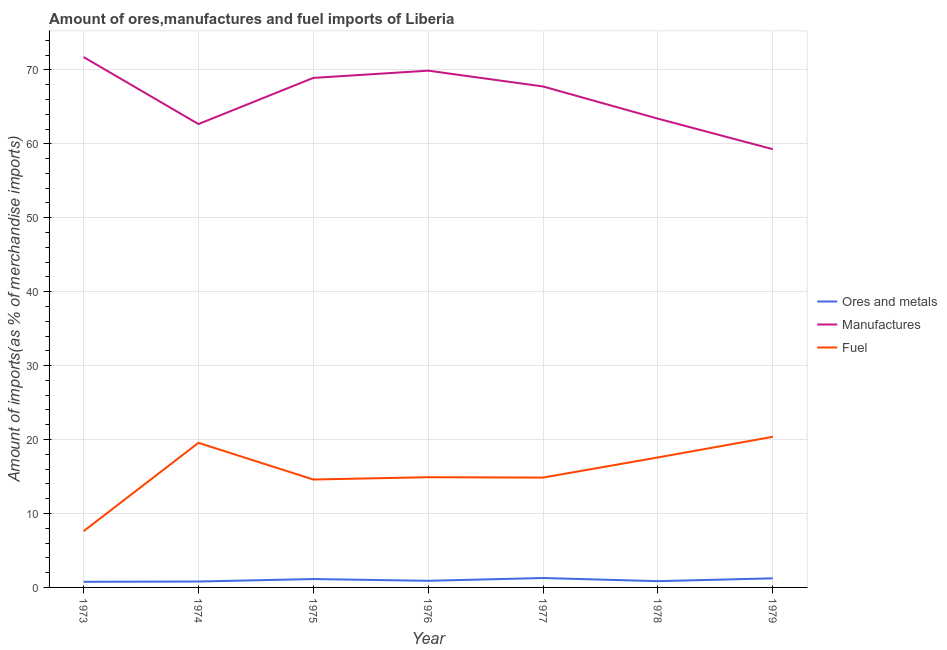How many different coloured lines are there?
Offer a terse response. 3. Does the line corresponding to percentage of fuel imports intersect with the line corresponding to percentage of ores and metals imports?
Offer a terse response. No. What is the percentage of manufactures imports in 1977?
Offer a very short reply. 67.76. Across all years, what is the maximum percentage of fuel imports?
Provide a short and direct response. 20.37. Across all years, what is the minimum percentage of manufactures imports?
Ensure brevity in your answer.  59.27. In which year was the percentage of fuel imports minimum?
Your answer should be very brief. 1973. What is the total percentage of manufactures imports in the graph?
Make the answer very short. 463.64. What is the difference between the percentage of fuel imports in 1975 and that in 1977?
Your answer should be compact. -0.26. What is the difference between the percentage of ores and metals imports in 1974 and the percentage of fuel imports in 1973?
Keep it short and to the point. -6.81. What is the average percentage of ores and metals imports per year?
Offer a terse response. 0.99. In the year 1975, what is the difference between the percentage of manufactures imports and percentage of ores and metals imports?
Your response must be concise. 67.78. In how many years, is the percentage of manufactures imports greater than 46 %?
Ensure brevity in your answer.  7. What is the ratio of the percentage of fuel imports in 1974 to that in 1977?
Keep it short and to the point. 1.32. Is the percentage of ores and metals imports in 1974 less than that in 1979?
Your answer should be very brief. Yes. Is the difference between the percentage of ores and metals imports in 1975 and 1976 greater than the difference between the percentage of fuel imports in 1975 and 1976?
Give a very brief answer. Yes. What is the difference between the highest and the second highest percentage of fuel imports?
Make the answer very short. 0.81. What is the difference between the highest and the lowest percentage of manufactures imports?
Offer a very short reply. 12.46. Is the sum of the percentage of manufactures imports in 1975 and 1977 greater than the maximum percentage of ores and metals imports across all years?
Ensure brevity in your answer.  Yes. Does the percentage of ores and metals imports monotonically increase over the years?
Your response must be concise. No. Is the percentage of ores and metals imports strictly greater than the percentage of fuel imports over the years?
Keep it short and to the point. No. Is the percentage of ores and metals imports strictly less than the percentage of manufactures imports over the years?
Offer a very short reply. Yes. How many lines are there?
Your response must be concise. 3. What is the difference between two consecutive major ticks on the Y-axis?
Keep it short and to the point. 10. Where does the legend appear in the graph?
Give a very brief answer. Center right. How many legend labels are there?
Make the answer very short. 3. What is the title of the graph?
Provide a succinct answer. Amount of ores,manufactures and fuel imports of Liberia. Does "Czech Republic" appear as one of the legend labels in the graph?
Your answer should be compact. No. What is the label or title of the Y-axis?
Your answer should be very brief. Amount of imports(as % of merchandise imports). What is the Amount of imports(as % of merchandise imports) of Ores and metals in 1973?
Keep it short and to the point. 0.76. What is the Amount of imports(as % of merchandise imports) of Manufactures in 1973?
Provide a short and direct response. 71.73. What is the Amount of imports(as % of merchandise imports) in Fuel in 1973?
Offer a terse response. 7.61. What is the Amount of imports(as % of merchandise imports) in Ores and metals in 1974?
Your answer should be very brief. 0.8. What is the Amount of imports(as % of merchandise imports) of Manufactures in 1974?
Offer a terse response. 62.67. What is the Amount of imports(as % of merchandise imports) of Fuel in 1974?
Your answer should be compact. 19.56. What is the Amount of imports(as % of merchandise imports) in Ores and metals in 1975?
Keep it short and to the point. 1.13. What is the Amount of imports(as % of merchandise imports) in Manufactures in 1975?
Offer a terse response. 68.91. What is the Amount of imports(as % of merchandise imports) of Fuel in 1975?
Make the answer very short. 14.6. What is the Amount of imports(as % of merchandise imports) of Ores and metals in 1976?
Offer a terse response. 0.9. What is the Amount of imports(as % of merchandise imports) in Manufactures in 1976?
Give a very brief answer. 69.89. What is the Amount of imports(as % of merchandise imports) of Fuel in 1976?
Provide a short and direct response. 14.91. What is the Amount of imports(as % of merchandise imports) in Ores and metals in 1977?
Provide a succinct answer. 1.27. What is the Amount of imports(as % of merchandise imports) in Manufactures in 1977?
Ensure brevity in your answer.  67.76. What is the Amount of imports(as % of merchandise imports) in Fuel in 1977?
Your answer should be very brief. 14.86. What is the Amount of imports(as % of merchandise imports) in Ores and metals in 1978?
Make the answer very short. 0.85. What is the Amount of imports(as % of merchandise imports) of Manufactures in 1978?
Offer a very short reply. 63.4. What is the Amount of imports(as % of merchandise imports) in Fuel in 1978?
Your answer should be compact. 17.58. What is the Amount of imports(as % of merchandise imports) in Ores and metals in 1979?
Give a very brief answer. 1.23. What is the Amount of imports(as % of merchandise imports) of Manufactures in 1979?
Offer a terse response. 59.27. What is the Amount of imports(as % of merchandise imports) of Fuel in 1979?
Give a very brief answer. 20.37. Across all years, what is the maximum Amount of imports(as % of merchandise imports) of Ores and metals?
Make the answer very short. 1.27. Across all years, what is the maximum Amount of imports(as % of merchandise imports) in Manufactures?
Provide a succinct answer. 71.73. Across all years, what is the maximum Amount of imports(as % of merchandise imports) in Fuel?
Ensure brevity in your answer.  20.37. Across all years, what is the minimum Amount of imports(as % of merchandise imports) in Ores and metals?
Offer a terse response. 0.76. Across all years, what is the minimum Amount of imports(as % of merchandise imports) in Manufactures?
Offer a very short reply. 59.27. Across all years, what is the minimum Amount of imports(as % of merchandise imports) in Fuel?
Make the answer very short. 7.61. What is the total Amount of imports(as % of merchandise imports) in Ores and metals in the graph?
Offer a terse response. 6.94. What is the total Amount of imports(as % of merchandise imports) in Manufactures in the graph?
Ensure brevity in your answer.  463.64. What is the total Amount of imports(as % of merchandise imports) of Fuel in the graph?
Your response must be concise. 109.47. What is the difference between the Amount of imports(as % of merchandise imports) in Ores and metals in 1973 and that in 1974?
Keep it short and to the point. -0.04. What is the difference between the Amount of imports(as % of merchandise imports) in Manufactures in 1973 and that in 1974?
Your answer should be very brief. 9.06. What is the difference between the Amount of imports(as % of merchandise imports) of Fuel in 1973 and that in 1974?
Ensure brevity in your answer.  -11.95. What is the difference between the Amount of imports(as % of merchandise imports) of Ores and metals in 1973 and that in 1975?
Your answer should be very brief. -0.37. What is the difference between the Amount of imports(as % of merchandise imports) in Manufactures in 1973 and that in 1975?
Make the answer very short. 2.82. What is the difference between the Amount of imports(as % of merchandise imports) of Fuel in 1973 and that in 1975?
Ensure brevity in your answer.  -6.99. What is the difference between the Amount of imports(as % of merchandise imports) in Ores and metals in 1973 and that in 1976?
Offer a very short reply. -0.14. What is the difference between the Amount of imports(as % of merchandise imports) of Manufactures in 1973 and that in 1976?
Give a very brief answer. 1.84. What is the difference between the Amount of imports(as % of merchandise imports) of Fuel in 1973 and that in 1976?
Provide a short and direct response. -7.3. What is the difference between the Amount of imports(as % of merchandise imports) of Ores and metals in 1973 and that in 1977?
Ensure brevity in your answer.  -0.51. What is the difference between the Amount of imports(as % of merchandise imports) of Manufactures in 1973 and that in 1977?
Give a very brief answer. 3.98. What is the difference between the Amount of imports(as % of merchandise imports) in Fuel in 1973 and that in 1977?
Your answer should be very brief. -7.25. What is the difference between the Amount of imports(as % of merchandise imports) in Ores and metals in 1973 and that in 1978?
Offer a very short reply. -0.09. What is the difference between the Amount of imports(as % of merchandise imports) in Manufactures in 1973 and that in 1978?
Ensure brevity in your answer.  8.33. What is the difference between the Amount of imports(as % of merchandise imports) in Fuel in 1973 and that in 1978?
Offer a terse response. -9.97. What is the difference between the Amount of imports(as % of merchandise imports) in Ores and metals in 1973 and that in 1979?
Your answer should be compact. -0.47. What is the difference between the Amount of imports(as % of merchandise imports) of Manufactures in 1973 and that in 1979?
Offer a terse response. 12.46. What is the difference between the Amount of imports(as % of merchandise imports) of Fuel in 1973 and that in 1979?
Your answer should be compact. -12.76. What is the difference between the Amount of imports(as % of merchandise imports) of Ores and metals in 1974 and that in 1975?
Make the answer very short. -0.33. What is the difference between the Amount of imports(as % of merchandise imports) in Manufactures in 1974 and that in 1975?
Give a very brief answer. -6.24. What is the difference between the Amount of imports(as % of merchandise imports) in Fuel in 1974 and that in 1975?
Your response must be concise. 4.96. What is the difference between the Amount of imports(as % of merchandise imports) in Ores and metals in 1974 and that in 1976?
Your answer should be compact. -0.1. What is the difference between the Amount of imports(as % of merchandise imports) in Manufactures in 1974 and that in 1976?
Provide a short and direct response. -7.22. What is the difference between the Amount of imports(as % of merchandise imports) of Fuel in 1974 and that in 1976?
Ensure brevity in your answer.  4.65. What is the difference between the Amount of imports(as % of merchandise imports) of Ores and metals in 1974 and that in 1977?
Keep it short and to the point. -0.48. What is the difference between the Amount of imports(as % of merchandise imports) in Manufactures in 1974 and that in 1977?
Make the answer very short. -5.08. What is the difference between the Amount of imports(as % of merchandise imports) in Fuel in 1974 and that in 1977?
Provide a succinct answer. 4.7. What is the difference between the Amount of imports(as % of merchandise imports) in Ores and metals in 1974 and that in 1978?
Ensure brevity in your answer.  -0.05. What is the difference between the Amount of imports(as % of merchandise imports) of Manufactures in 1974 and that in 1978?
Offer a terse response. -0.73. What is the difference between the Amount of imports(as % of merchandise imports) of Fuel in 1974 and that in 1978?
Keep it short and to the point. 1.98. What is the difference between the Amount of imports(as % of merchandise imports) of Ores and metals in 1974 and that in 1979?
Offer a terse response. -0.43. What is the difference between the Amount of imports(as % of merchandise imports) in Manufactures in 1974 and that in 1979?
Offer a very short reply. 3.4. What is the difference between the Amount of imports(as % of merchandise imports) in Fuel in 1974 and that in 1979?
Ensure brevity in your answer.  -0.81. What is the difference between the Amount of imports(as % of merchandise imports) in Ores and metals in 1975 and that in 1976?
Keep it short and to the point. 0.24. What is the difference between the Amount of imports(as % of merchandise imports) of Manufactures in 1975 and that in 1976?
Your answer should be very brief. -0.98. What is the difference between the Amount of imports(as % of merchandise imports) in Fuel in 1975 and that in 1976?
Your answer should be very brief. -0.31. What is the difference between the Amount of imports(as % of merchandise imports) of Ores and metals in 1975 and that in 1977?
Your answer should be very brief. -0.14. What is the difference between the Amount of imports(as % of merchandise imports) of Manufactures in 1975 and that in 1977?
Your response must be concise. 1.16. What is the difference between the Amount of imports(as % of merchandise imports) of Fuel in 1975 and that in 1977?
Your answer should be compact. -0.26. What is the difference between the Amount of imports(as % of merchandise imports) in Ores and metals in 1975 and that in 1978?
Ensure brevity in your answer.  0.29. What is the difference between the Amount of imports(as % of merchandise imports) in Manufactures in 1975 and that in 1978?
Offer a very short reply. 5.51. What is the difference between the Amount of imports(as % of merchandise imports) in Fuel in 1975 and that in 1978?
Provide a short and direct response. -2.98. What is the difference between the Amount of imports(as % of merchandise imports) in Ores and metals in 1975 and that in 1979?
Your answer should be very brief. -0.1. What is the difference between the Amount of imports(as % of merchandise imports) in Manufactures in 1975 and that in 1979?
Provide a succinct answer. 9.64. What is the difference between the Amount of imports(as % of merchandise imports) in Fuel in 1975 and that in 1979?
Ensure brevity in your answer.  -5.78. What is the difference between the Amount of imports(as % of merchandise imports) in Ores and metals in 1976 and that in 1977?
Your answer should be very brief. -0.38. What is the difference between the Amount of imports(as % of merchandise imports) in Manufactures in 1976 and that in 1977?
Your response must be concise. 2.14. What is the difference between the Amount of imports(as % of merchandise imports) of Fuel in 1976 and that in 1977?
Offer a very short reply. 0.05. What is the difference between the Amount of imports(as % of merchandise imports) in Ores and metals in 1976 and that in 1978?
Offer a very short reply. 0.05. What is the difference between the Amount of imports(as % of merchandise imports) in Manufactures in 1976 and that in 1978?
Make the answer very short. 6.49. What is the difference between the Amount of imports(as % of merchandise imports) in Fuel in 1976 and that in 1978?
Your answer should be compact. -2.67. What is the difference between the Amount of imports(as % of merchandise imports) of Ores and metals in 1976 and that in 1979?
Make the answer very short. -0.34. What is the difference between the Amount of imports(as % of merchandise imports) in Manufactures in 1976 and that in 1979?
Keep it short and to the point. 10.62. What is the difference between the Amount of imports(as % of merchandise imports) of Fuel in 1976 and that in 1979?
Offer a terse response. -5.46. What is the difference between the Amount of imports(as % of merchandise imports) of Ores and metals in 1977 and that in 1978?
Provide a succinct answer. 0.43. What is the difference between the Amount of imports(as % of merchandise imports) of Manufactures in 1977 and that in 1978?
Make the answer very short. 4.35. What is the difference between the Amount of imports(as % of merchandise imports) in Fuel in 1977 and that in 1978?
Provide a succinct answer. -2.72. What is the difference between the Amount of imports(as % of merchandise imports) in Ores and metals in 1977 and that in 1979?
Your answer should be compact. 0.04. What is the difference between the Amount of imports(as % of merchandise imports) of Manufactures in 1977 and that in 1979?
Offer a terse response. 8.48. What is the difference between the Amount of imports(as % of merchandise imports) of Fuel in 1977 and that in 1979?
Make the answer very short. -5.51. What is the difference between the Amount of imports(as % of merchandise imports) of Ores and metals in 1978 and that in 1979?
Give a very brief answer. -0.38. What is the difference between the Amount of imports(as % of merchandise imports) of Manufactures in 1978 and that in 1979?
Your answer should be very brief. 4.13. What is the difference between the Amount of imports(as % of merchandise imports) in Fuel in 1978 and that in 1979?
Make the answer very short. -2.79. What is the difference between the Amount of imports(as % of merchandise imports) of Ores and metals in 1973 and the Amount of imports(as % of merchandise imports) of Manufactures in 1974?
Provide a short and direct response. -61.91. What is the difference between the Amount of imports(as % of merchandise imports) of Ores and metals in 1973 and the Amount of imports(as % of merchandise imports) of Fuel in 1974?
Your answer should be compact. -18.8. What is the difference between the Amount of imports(as % of merchandise imports) of Manufactures in 1973 and the Amount of imports(as % of merchandise imports) of Fuel in 1974?
Provide a succinct answer. 52.17. What is the difference between the Amount of imports(as % of merchandise imports) in Ores and metals in 1973 and the Amount of imports(as % of merchandise imports) in Manufactures in 1975?
Ensure brevity in your answer.  -68.15. What is the difference between the Amount of imports(as % of merchandise imports) of Ores and metals in 1973 and the Amount of imports(as % of merchandise imports) of Fuel in 1975?
Provide a short and direct response. -13.83. What is the difference between the Amount of imports(as % of merchandise imports) of Manufactures in 1973 and the Amount of imports(as % of merchandise imports) of Fuel in 1975?
Provide a succinct answer. 57.14. What is the difference between the Amount of imports(as % of merchandise imports) of Ores and metals in 1973 and the Amount of imports(as % of merchandise imports) of Manufactures in 1976?
Your answer should be compact. -69.13. What is the difference between the Amount of imports(as % of merchandise imports) in Ores and metals in 1973 and the Amount of imports(as % of merchandise imports) in Fuel in 1976?
Provide a succinct answer. -14.15. What is the difference between the Amount of imports(as % of merchandise imports) of Manufactures in 1973 and the Amount of imports(as % of merchandise imports) of Fuel in 1976?
Provide a succinct answer. 56.83. What is the difference between the Amount of imports(as % of merchandise imports) in Ores and metals in 1973 and the Amount of imports(as % of merchandise imports) in Manufactures in 1977?
Give a very brief answer. -66.99. What is the difference between the Amount of imports(as % of merchandise imports) of Ores and metals in 1973 and the Amount of imports(as % of merchandise imports) of Fuel in 1977?
Keep it short and to the point. -14.1. What is the difference between the Amount of imports(as % of merchandise imports) in Manufactures in 1973 and the Amount of imports(as % of merchandise imports) in Fuel in 1977?
Offer a terse response. 56.88. What is the difference between the Amount of imports(as % of merchandise imports) in Ores and metals in 1973 and the Amount of imports(as % of merchandise imports) in Manufactures in 1978?
Provide a succinct answer. -62.64. What is the difference between the Amount of imports(as % of merchandise imports) in Ores and metals in 1973 and the Amount of imports(as % of merchandise imports) in Fuel in 1978?
Your answer should be compact. -16.82. What is the difference between the Amount of imports(as % of merchandise imports) in Manufactures in 1973 and the Amount of imports(as % of merchandise imports) in Fuel in 1978?
Provide a succinct answer. 54.15. What is the difference between the Amount of imports(as % of merchandise imports) in Ores and metals in 1973 and the Amount of imports(as % of merchandise imports) in Manufactures in 1979?
Offer a very short reply. -58.51. What is the difference between the Amount of imports(as % of merchandise imports) of Ores and metals in 1973 and the Amount of imports(as % of merchandise imports) of Fuel in 1979?
Make the answer very short. -19.61. What is the difference between the Amount of imports(as % of merchandise imports) in Manufactures in 1973 and the Amount of imports(as % of merchandise imports) in Fuel in 1979?
Ensure brevity in your answer.  51.36. What is the difference between the Amount of imports(as % of merchandise imports) of Ores and metals in 1974 and the Amount of imports(as % of merchandise imports) of Manufactures in 1975?
Provide a succinct answer. -68.12. What is the difference between the Amount of imports(as % of merchandise imports) of Ores and metals in 1974 and the Amount of imports(as % of merchandise imports) of Fuel in 1975?
Your response must be concise. -13.8. What is the difference between the Amount of imports(as % of merchandise imports) in Manufactures in 1974 and the Amount of imports(as % of merchandise imports) in Fuel in 1975?
Offer a very short reply. 48.08. What is the difference between the Amount of imports(as % of merchandise imports) of Ores and metals in 1974 and the Amount of imports(as % of merchandise imports) of Manufactures in 1976?
Your response must be concise. -69.09. What is the difference between the Amount of imports(as % of merchandise imports) in Ores and metals in 1974 and the Amount of imports(as % of merchandise imports) in Fuel in 1976?
Offer a terse response. -14.11. What is the difference between the Amount of imports(as % of merchandise imports) of Manufactures in 1974 and the Amount of imports(as % of merchandise imports) of Fuel in 1976?
Offer a terse response. 47.76. What is the difference between the Amount of imports(as % of merchandise imports) in Ores and metals in 1974 and the Amount of imports(as % of merchandise imports) in Manufactures in 1977?
Your answer should be compact. -66.96. What is the difference between the Amount of imports(as % of merchandise imports) of Ores and metals in 1974 and the Amount of imports(as % of merchandise imports) of Fuel in 1977?
Keep it short and to the point. -14.06. What is the difference between the Amount of imports(as % of merchandise imports) of Manufactures in 1974 and the Amount of imports(as % of merchandise imports) of Fuel in 1977?
Keep it short and to the point. 47.82. What is the difference between the Amount of imports(as % of merchandise imports) of Ores and metals in 1974 and the Amount of imports(as % of merchandise imports) of Manufactures in 1978?
Make the answer very short. -62.6. What is the difference between the Amount of imports(as % of merchandise imports) in Ores and metals in 1974 and the Amount of imports(as % of merchandise imports) in Fuel in 1978?
Ensure brevity in your answer.  -16.78. What is the difference between the Amount of imports(as % of merchandise imports) in Manufactures in 1974 and the Amount of imports(as % of merchandise imports) in Fuel in 1978?
Your answer should be very brief. 45.09. What is the difference between the Amount of imports(as % of merchandise imports) of Ores and metals in 1974 and the Amount of imports(as % of merchandise imports) of Manufactures in 1979?
Provide a succinct answer. -58.47. What is the difference between the Amount of imports(as % of merchandise imports) of Ores and metals in 1974 and the Amount of imports(as % of merchandise imports) of Fuel in 1979?
Ensure brevity in your answer.  -19.57. What is the difference between the Amount of imports(as % of merchandise imports) in Manufactures in 1974 and the Amount of imports(as % of merchandise imports) in Fuel in 1979?
Make the answer very short. 42.3. What is the difference between the Amount of imports(as % of merchandise imports) of Ores and metals in 1975 and the Amount of imports(as % of merchandise imports) of Manufactures in 1976?
Ensure brevity in your answer.  -68.76. What is the difference between the Amount of imports(as % of merchandise imports) in Ores and metals in 1975 and the Amount of imports(as % of merchandise imports) in Fuel in 1976?
Your answer should be compact. -13.77. What is the difference between the Amount of imports(as % of merchandise imports) in Manufactures in 1975 and the Amount of imports(as % of merchandise imports) in Fuel in 1976?
Your answer should be very brief. 54.01. What is the difference between the Amount of imports(as % of merchandise imports) in Ores and metals in 1975 and the Amount of imports(as % of merchandise imports) in Manufactures in 1977?
Make the answer very short. -66.62. What is the difference between the Amount of imports(as % of merchandise imports) of Ores and metals in 1975 and the Amount of imports(as % of merchandise imports) of Fuel in 1977?
Ensure brevity in your answer.  -13.72. What is the difference between the Amount of imports(as % of merchandise imports) in Manufactures in 1975 and the Amount of imports(as % of merchandise imports) in Fuel in 1977?
Your answer should be compact. 54.06. What is the difference between the Amount of imports(as % of merchandise imports) of Ores and metals in 1975 and the Amount of imports(as % of merchandise imports) of Manufactures in 1978?
Make the answer very short. -62.27. What is the difference between the Amount of imports(as % of merchandise imports) in Ores and metals in 1975 and the Amount of imports(as % of merchandise imports) in Fuel in 1978?
Make the answer very short. -16.45. What is the difference between the Amount of imports(as % of merchandise imports) in Manufactures in 1975 and the Amount of imports(as % of merchandise imports) in Fuel in 1978?
Provide a short and direct response. 51.34. What is the difference between the Amount of imports(as % of merchandise imports) of Ores and metals in 1975 and the Amount of imports(as % of merchandise imports) of Manufactures in 1979?
Ensure brevity in your answer.  -58.14. What is the difference between the Amount of imports(as % of merchandise imports) of Ores and metals in 1975 and the Amount of imports(as % of merchandise imports) of Fuel in 1979?
Your answer should be very brief. -19.24. What is the difference between the Amount of imports(as % of merchandise imports) in Manufactures in 1975 and the Amount of imports(as % of merchandise imports) in Fuel in 1979?
Offer a terse response. 48.54. What is the difference between the Amount of imports(as % of merchandise imports) of Ores and metals in 1976 and the Amount of imports(as % of merchandise imports) of Manufactures in 1977?
Keep it short and to the point. -66.86. What is the difference between the Amount of imports(as % of merchandise imports) in Ores and metals in 1976 and the Amount of imports(as % of merchandise imports) in Fuel in 1977?
Your answer should be compact. -13.96. What is the difference between the Amount of imports(as % of merchandise imports) of Manufactures in 1976 and the Amount of imports(as % of merchandise imports) of Fuel in 1977?
Your response must be concise. 55.04. What is the difference between the Amount of imports(as % of merchandise imports) of Ores and metals in 1976 and the Amount of imports(as % of merchandise imports) of Manufactures in 1978?
Your answer should be compact. -62.51. What is the difference between the Amount of imports(as % of merchandise imports) in Ores and metals in 1976 and the Amount of imports(as % of merchandise imports) in Fuel in 1978?
Give a very brief answer. -16.68. What is the difference between the Amount of imports(as % of merchandise imports) in Manufactures in 1976 and the Amount of imports(as % of merchandise imports) in Fuel in 1978?
Provide a short and direct response. 52.31. What is the difference between the Amount of imports(as % of merchandise imports) in Ores and metals in 1976 and the Amount of imports(as % of merchandise imports) in Manufactures in 1979?
Make the answer very short. -58.38. What is the difference between the Amount of imports(as % of merchandise imports) of Ores and metals in 1976 and the Amount of imports(as % of merchandise imports) of Fuel in 1979?
Provide a succinct answer. -19.47. What is the difference between the Amount of imports(as % of merchandise imports) in Manufactures in 1976 and the Amount of imports(as % of merchandise imports) in Fuel in 1979?
Your answer should be compact. 49.52. What is the difference between the Amount of imports(as % of merchandise imports) in Ores and metals in 1977 and the Amount of imports(as % of merchandise imports) in Manufactures in 1978?
Provide a succinct answer. -62.13. What is the difference between the Amount of imports(as % of merchandise imports) in Ores and metals in 1977 and the Amount of imports(as % of merchandise imports) in Fuel in 1978?
Your answer should be very brief. -16.3. What is the difference between the Amount of imports(as % of merchandise imports) of Manufactures in 1977 and the Amount of imports(as % of merchandise imports) of Fuel in 1978?
Provide a short and direct response. 50.18. What is the difference between the Amount of imports(as % of merchandise imports) in Ores and metals in 1977 and the Amount of imports(as % of merchandise imports) in Manufactures in 1979?
Your answer should be very brief. -58. What is the difference between the Amount of imports(as % of merchandise imports) in Ores and metals in 1977 and the Amount of imports(as % of merchandise imports) in Fuel in 1979?
Ensure brevity in your answer.  -19.1. What is the difference between the Amount of imports(as % of merchandise imports) of Manufactures in 1977 and the Amount of imports(as % of merchandise imports) of Fuel in 1979?
Provide a succinct answer. 47.38. What is the difference between the Amount of imports(as % of merchandise imports) of Ores and metals in 1978 and the Amount of imports(as % of merchandise imports) of Manufactures in 1979?
Make the answer very short. -58.43. What is the difference between the Amount of imports(as % of merchandise imports) in Ores and metals in 1978 and the Amount of imports(as % of merchandise imports) in Fuel in 1979?
Offer a very short reply. -19.52. What is the difference between the Amount of imports(as % of merchandise imports) of Manufactures in 1978 and the Amount of imports(as % of merchandise imports) of Fuel in 1979?
Your answer should be very brief. 43.03. What is the average Amount of imports(as % of merchandise imports) in Ores and metals per year?
Your answer should be compact. 0.99. What is the average Amount of imports(as % of merchandise imports) in Manufactures per year?
Ensure brevity in your answer.  66.23. What is the average Amount of imports(as % of merchandise imports) in Fuel per year?
Provide a short and direct response. 15.64. In the year 1973, what is the difference between the Amount of imports(as % of merchandise imports) of Ores and metals and Amount of imports(as % of merchandise imports) of Manufactures?
Give a very brief answer. -70.97. In the year 1973, what is the difference between the Amount of imports(as % of merchandise imports) of Ores and metals and Amount of imports(as % of merchandise imports) of Fuel?
Ensure brevity in your answer.  -6.85. In the year 1973, what is the difference between the Amount of imports(as % of merchandise imports) in Manufactures and Amount of imports(as % of merchandise imports) in Fuel?
Your answer should be compact. 64.12. In the year 1974, what is the difference between the Amount of imports(as % of merchandise imports) of Ores and metals and Amount of imports(as % of merchandise imports) of Manufactures?
Offer a very short reply. -61.87. In the year 1974, what is the difference between the Amount of imports(as % of merchandise imports) of Ores and metals and Amount of imports(as % of merchandise imports) of Fuel?
Make the answer very short. -18.76. In the year 1974, what is the difference between the Amount of imports(as % of merchandise imports) in Manufactures and Amount of imports(as % of merchandise imports) in Fuel?
Your answer should be compact. 43.11. In the year 1975, what is the difference between the Amount of imports(as % of merchandise imports) in Ores and metals and Amount of imports(as % of merchandise imports) in Manufactures?
Give a very brief answer. -67.78. In the year 1975, what is the difference between the Amount of imports(as % of merchandise imports) in Ores and metals and Amount of imports(as % of merchandise imports) in Fuel?
Your answer should be very brief. -13.46. In the year 1975, what is the difference between the Amount of imports(as % of merchandise imports) of Manufactures and Amount of imports(as % of merchandise imports) of Fuel?
Provide a succinct answer. 54.32. In the year 1976, what is the difference between the Amount of imports(as % of merchandise imports) of Ores and metals and Amount of imports(as % of merchandise imports) of Manufactures?
Give a very brief answer. -69. In the year 1976, what is the difference between the Amount of imports(as % of merchandise imports) in Ores and metals and Amount of imports(as % of merchandise imports) in Fuel?
Ensure brevity in your answer.  -14.01. In the year 1976, what is the difference between the Amount of imports(as % of merchandise imports) in Manufactures and Amount of imports(as % of merchandise imports) in Fuel?
Keep it short and to the point. 54.99. In the year 1977, what is the difference between the Amount of imports(as % of merchandise imports) of Ores and metals and Amount of imports(as % of merchandise imports) of Manufactures?
Keep it short and to the point. -66.48. In the year 1977, what is the difference between the Amount of imports(as % of merchandise imports) of Ores and metals and Amount of imports(as % of merchandise imports) of Fuel?
Make the answer very short. -13.58. In the year 1977, what is the difference between the Amount of imports(as % of merchandise imports) of Manufactures and Amount of imports(as % of merchandise imports) of Fuel?
Ensure brevity in your answer.  52.9. In the year 1978, what is the difference between the Amount of imports(as % of merchandise imports) in Ores and metals and Amount of imports(as % of merchandise imports) in Manufactures?
Provide a succinct answer. -62.56. In the year 1978, what is the difference between the Amount of imports(as % of merchandise imports) in Ores and metals and Amount of imports(as % of merchandise imports) in Fuel?
Your answer should be very brief. -16.73. In the year 1978, what is the difference between the Amount of imports(as % of merchandise imports) of Manufactures and Amount of imports(as % of merchandise imports) of Fuel?
Your answer should be compact. 45.82. In the year 1979, what is the difference between the Amount of imports(as % of merchandise imports) of Ores and metals and Amount of imports(as % of merchandise imports) of Manufactures?
Offer a terse response. -58.04. In the year 1979, what is the difference between the Amount of imports(as % of merchandise imports) of Ores and metals and Amount of imports(as % of merchandise imports) of Fuel?
Make the answer very short. -19.14. In the year 1979, what is the difference between the Amount of imports(as % of merchandise imports) of Manufactures and Amount of imports(as % of merchandise imports) of Fuel?
Give a very brief answer. 38.9. What is the ratio of the Amount of imports(as % of merchandise imports) of Ores and metals in 1973 to that in 1974?
Your answer should be very brief. 0.95. What is the ratio of the Amount of imports(as % of merchandise imports) of Manufactures in 1973 to that in 1974?
Your answer should be compact. 1.14. What is the ratio of the Amount of imports(as % of merchandise imports) in Fuel in 1973 to that in 1974?
Offer a terse response. 0.39. What is the ratio of the Amount of imports(as % of merchandise imports) in Ores and metals in 1973 to that in 1975?
Your answer should be compact. 0.67. What is the ratio of the Amount of imports(as % of merchandise imports) of Manufactures in 1973 to that in 1975?
Your answer should be compact. 1.04. What is the ratio of the Amount of imports(as % of merchandise imports) in Fuel in 1973 to that in 1975?
Your answer should be very brief. 0.52. What is the ratio of the Amount of imports(as % of merchandise imports) in Ores and metals in 1973 to that in 1976?
Give a very brief answer. 0.85. What is the ratio of the Amount of imports(as % of merchandise imports) in Manufactures in 1973 to that in 1976?
Ensure brevity in your answer.  1.03. What is the ratio of the Amount of imports(as % of merchandise imports) in Fuel in 1973 to that in 1976?
Your response must be concise. 0.51. What is the ratio of the Amount of imports(as % of merchandise imports) in Ores and metals in 1973 to that in 1977?
Ensure brevity in your answer.  0.6. What is the ratio of the Amount of imports(as % of merchandise imports) of Manufactures in 1973 to that in 1977?
Offer a very short reply. 1.06. What is the ratio of the Amount of imports(as % of merchandise imports) of Fuel in 1973 to that in 1977?
Ensure brevity in your answer.  0.51. What is the ratio of the Amount of imports(as % of merchandise imports) in Ores and metals in 1973 to that in 1978?
Provide a short and direct response. 0.9. What is the ratio of the Amount of imports(as % of merchandise imports) in Manufactures in 1973 to that in 1978?
Make the answer very short. 1.13. What is the ratio of the Amount of imports(as % of merchandise imports) of Fuel in 1973 to that in 1978?
Your answer should be very brief. 0.43. What is the ratio of the Amount of imports(as % of merchandise imports) in Ores and metals in 1973 to that in 1979?
Provide a succinct answer. 0.62. What is the ratio of the Amount of imports(as % of merchandise imports) of Manufactures in 1973 to that in 1979?
Give a very brief answer. 1.21. What is the ratio of the Amount of imports(as % of merchandise imports) of Fuel in 1973 to that in 1979?
Provide a short and direct response. 0.37. What is the ratio of the Amount of imports(as % of merchandise imports) in Ores and metals in 1974 to that in 1975?
Your answer should be compact. 0.7. What is the ratio of the Amount of imports(as % of merchandise imports) in Manufactures in 1974 to that in 1975?
Your answer should be very brief. 0.91. What is the ratio of the Amount of imports(as % of merchandise imports) in Fuel in 1974 to that in 1975?
Make the answer very short. 1.34. What is the ratio of the Amount of imports(as % of merchandise imports) of Ores and metals in 1974 to that in 1976?
Make the answer very short. 0.89. What is the ratio of the Amount of imports(as % of merchandise imports) in Manufactures in 1974 to that in 1976?
Your response must be concise. 0.9. What is the ratio of the Amount of imports(as % of merchandise imports) in Fuel in 1974 to that in 1976?
Provide a succinct answer. 1.31. What is the ratio of the Amount of imports(as % of merchandise imports) of Ores and metals in 1974 to that in 1977?
Make the answer very short. 0.63. What is the ratio of the Amount of imports(as % of merchandise imports) in Manufactures in 1974 to that in 1977?
Give a very brief answer. 0.93. What is the ratio of the Amount of imports(as % of merchandise imports) in Fuel in 1974 to that in 1977?
Your answer should be compact. 1.32. What is the ratio of the Amount of imports(as % of merchandise imports) in Ores and metals in 1974 to that in 1978?
Give a very brief answer. 0.94. What is the ratio of the Amount of imports(as % of merchandise imports) of Manufactures in 1974 to that in 1978?
Keep it short and to the point. 0.99. What is the ratio of the Amount of imports(as % of merchandise imports) in Fuel in 1974 to that in 1978?
Provide a short and direct response. 1.11. What is the ratio of the Amount of imports(as % of merchandise imports) of Ores and metals in 1974 to that in 1979?
Your answer should be very brief. 0.65. What is the ratio of the Amount of imports(as % of merchandise imports) of Manufactures in 1974 to that in 1979?
Give a very brief answer. 1.06. What is the ratio of the Amount of imports(as % of merchandise imports) in Fuel in 1974 to that in 1979?
Keep it short and to the point. 0.96. What is the ratio of the Amount of imports(as % of merchandise imports) in Ores and metals in 1975 to that in 1976?
Your answer should be compact. 1.26. What is the ratio of the Amount of imports(as % of merchandise imports) in Manufactures in 1975 to that in 1976?
Keep it short and to the point. 0.99. What is the ratio of the Amount of imports(as % of merchandise imports) in Fuel in 1975 to that in 1976?
Your response must be concise. 0.98. What is the ratio of the Amount of imports(as % of merchandise imports) of Ores and metals in 1975 to that in 1977?
Ensure brevity in your answer.  0.89. What is the ratio of the Amount of imports(as % of merchandise imports) of Manufactures in 1975 to that in 1977?
Offer a very short reply. 1.02. What is the ratio of the Amount of imports(as % of merchandise imports) of Fuel in 1975 to that in 1977?
Your response must be concise. 0.98. What is the ratio of the Amount of imports(as % of merchandise imports) of Ores and metals in 1975 to that in 1978?
Keep it short and to the point. 1.34. What is the ratio of the Amount of imports(as % of merchandise imports) in Manufactures in 1975 to that in 1978?
Provide a succinct answer. 1.09. What is the ratio of the Amount of imports(as % of merchandise imports) in Fuel in 1975 to that in 1978?
Ensure brevity in your answer.  0.83. What is the ratio of the Amount of imports(as % of merchandise imports) of Ores and metals in 1975 to that in 1979?
Make the answer very short. 0.92. What is the ratio of the Amount of imports(as % of merchandise imports) in Manufactures in 1975 to that in 1979?
Give a very brief answer. 1.16. What is the ratio of the Amount of imports(as % of merchandise imports) of Fuel in 1975 to that in 1979?
Give a very brief answer. 0.72. What is the ratio of the Amount of imports(as % of merchandise imports) of Ores and metals in 1976 to that in 1977?
Give a very brief answer. 0.7. What is the ratio of the Amount of imports(as % of merchandise imports) of Manufactures in 1976 to that in 1977?
Offer a terse response. 1.03. What is the ratio of the Amount of imports(as % of merchandise imports) of Fuel in 1976 to that in 1977?
Offer a very short reply. 1. What is the ratio of the Amount of imports(as % of merchandise imports) of Ores and metals in 1976 to that in 1978?
Make the answer very short. 1.06. What is the ratio of the Amount of imports(as % of merchandise imports) of Manufactures in 1976 to that in 1978?
Keep it short and to the point. 1.1. What is the ratio of the Amount of imports(as % of merchandise imports) in Fuel in 1976 to that in 1978?
Your response must be concise. 0.85. What is the ratio of the Amount of imports(as % of merchandise imports) in Ores and metals in 1976 to that in 1979?
Offer a terse response. 0.73. What is the ratio of the Amount of imports(as % of merchandise imports) of Manufactures in 1976 to that in 1979?
Your answer should be compact. 1.18. What is the ratio of the Amount of imports(as % of merchandise imports) of Fuel in 1976 to that in 1979?
Your response must be concise. 0.73. What is the ratio of the Amount of imports(as % of merchandise imports) in Ores and metals in 1977 to that in 1978?
Offer a terse response. 1.5. What is the ratio of the Amount of imports(as % of merchandise imports) in Manufactures in 1977 to that in 1978?
Offer a very short reply. 1.07. What is the ratio of the Amount of imports(as % of merchandise imports) in Fuel in 1977 to that in 1978?
Make the answer very short. 0.85. What is the ratio of the Amount of imports(as % of merchandise imports) of Ores and metals in 1977 to that in 1979?
Keep it short and to the point. 1.03. What is the ratio of the Amount of imports(as % of merchandise imports) in Manufactures in 1977 to that in 1979?
Your answer should be very brief. 1.14. What is the ratio of the Amount of imports(as % of merchandise imports) of Fuel in 1977 to that in 1979?
Offer a very short reply. 0.73. What is the ratio of the Amount of imports(as % of merchandise imports) in Ores and metals in 1978 to that in 1979?
Your response must be concise. 0.69. What is the ratio of the Amount of imports(as % of merchandise imports) of Manufactures in 1978 to that in 1979?
Offer a terse response. 1.07. What is the ratio of the Amount of imports(as % of merchandise imports) of Fuel in 1978 to that in 1979?
Offer a terse response. 0.86. What is the difference between the highest and the second highest Amount of imports(as % of merchandise imports) of Ores and metals?
Give a very brief answer. 0.04. What is the difference between the highest and the second highest Amount of imports(as % of merchandise imports) of Manufactures?
Offer a terse response. 1.84. What is the difference between the highest and the second highest Amount of imports(as % of merchandise imports) in Fuel?
Provide a short and direct response. 0.81. What is the difference between the highest and the lowest Amount of imports(as % of merchandise imports) in Ores and metals?
Your response must be concise. 0.51. What is the difference between the highest and the lowest Amount of imports(as % of merchandise imports) of Manufactures?
Offer a very short reply. 12.46. What is the difference between the highest and the lowest Amount of imports(as % of merchandise imports) in Fuel?
Keep it short and to the point. 12.76. 